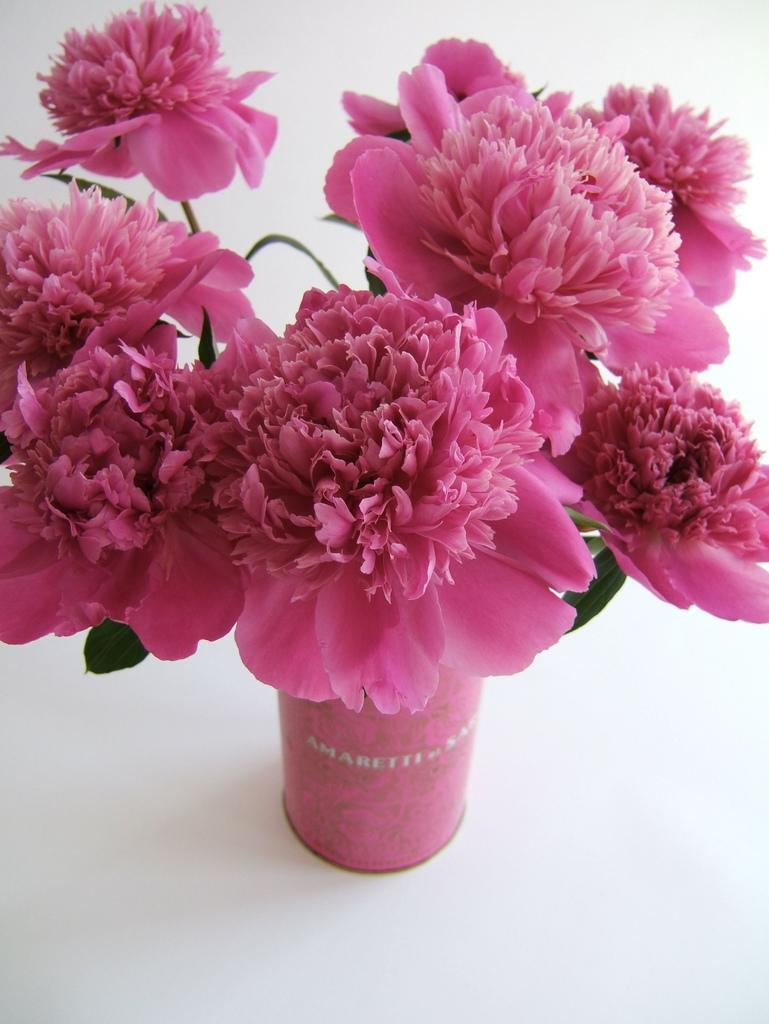What type of plant can be seen in the image? There is a plant in the image. What are the flowers like in the image? There are flowers in the image, and they are pink in color. Where are the flowers located in the image? The flowers are on the floor in the image. How does the plant contribute to the quiet atmosphere in the image? The image does not convey any information about the atmosphere or noise level, so it is not possible to determine how the plant contributes to the quiet atmosphere. 